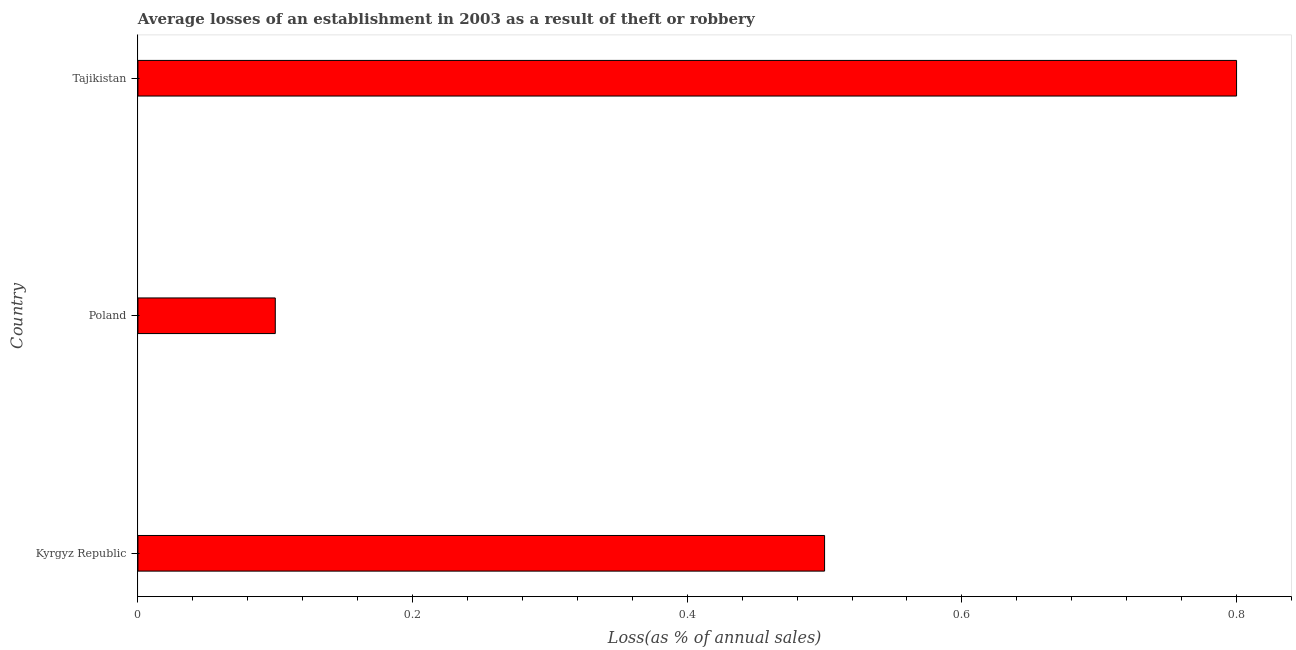What is the title of the graph?
Offer a very short reply. Average losses of an establishment in 2003 as a result of theft or robbery. What is the label or title of the X-axis?
Your response must be concise. Loss(as % of annual sales). Across all countries, what is the maximum losses due to theft?
Provide a short and direct response. 0.8. In which country was the losses due to theft maximum?
Provide a short and direct response. Tajikistan. What is the difference between the losses due to theft in Poland and Tajikistan?
Your response must be concise. -0.7. What is the average losses due to theft per country?
Keep it short and to the point. 0.47. What is the median losses due to theft?
Offer a terse response. 0.5. Is the sum of the losses due to theft in Kyrgyz Republic and Poland greater than the maximum losses due to theft across all countries?
Your response must be concise. No. How many bars are there?
Provide a short and direct response. 3. What is the Loss(as % of annual sales) in Kyrgyz Republic?
Your answer should be very brief. 0.5. What is the Loss(as % of annual sales) in Poland?
Keep it short and to the point. 0.1. What is the difference between the Loss(as % of annual sales) in Kyrgyz Republic and Poland?
Provide a succinct answer. 0.4. What is the difference between the Loss(as % of annual sales) in Kyrgyz Republic and Tajikistan?
Your response must be concise. -0.3. What is the difference between the Loss(as % of annual sales) in Poland and Tajikistan?
Provide a succinct answer. -0.7. What is the ratio of the Loss(as % of annual sales) in Kyrgyz Republic to that in Poland?
Provide a succinct answer. 5. What is the ratio of the Loss(as % of annual sales) in Poland to that in Tajikistan?
Provide a succinct answer. 0.12. 